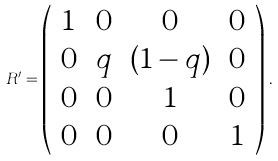Convert formula to latex. <formula><loc_0><loc_0><loc_500><loc_500>R ^ { \prime } = \left ( \begin{array} { c c c c } 1 & 0 & 0 & 0 \\ 0 & q & ( 1 - q ) & 0 \\ 0 & 0 & 1 & 0 \\ 0 & 0 & 0 & 1 \end{array} \right ) \, .</formula> 